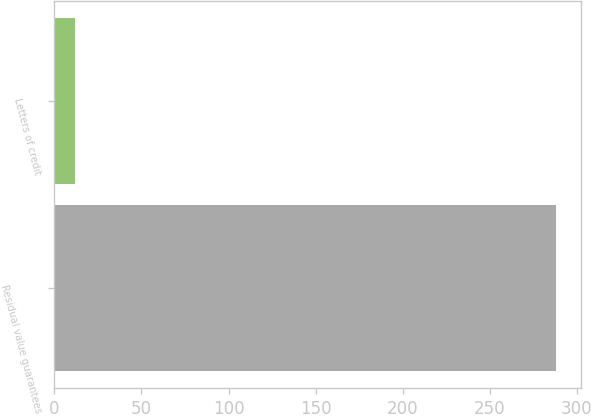<chart> <loc_0><loc_0><loc_500><loc_500><bar_chart><fcel>Residual value guarantees<fcel>Letters of credit<nl><fcel>287.8<fcel>11.7<nl></chart> 